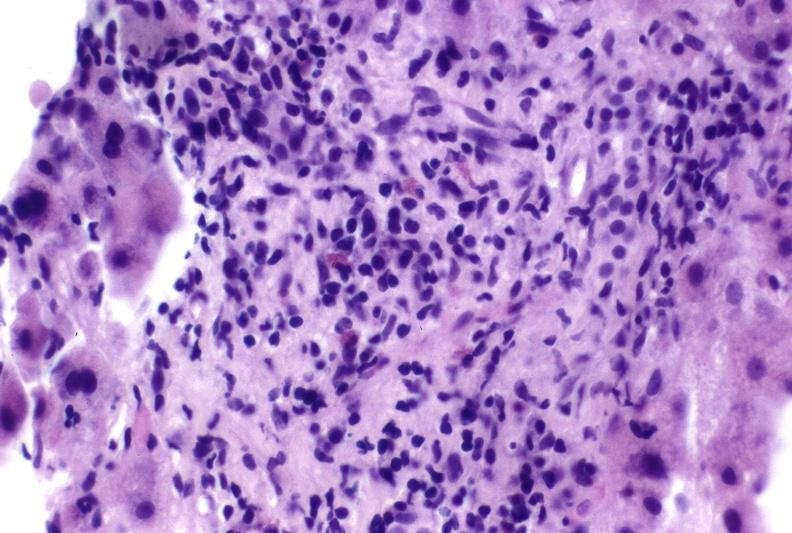does foot show autoimmune hepatitis?
Answer the question using a single word or phrase. No 